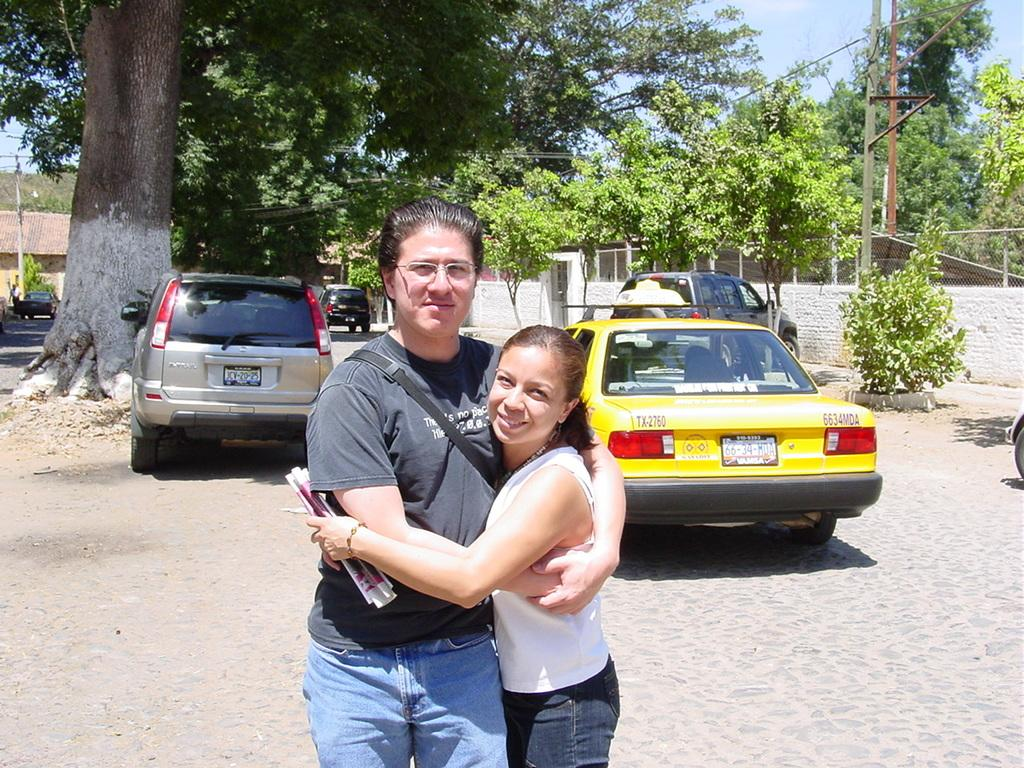<image>
Render a clear and concise summary of the photo. A yellow car has the label 6634MDA on the back. 